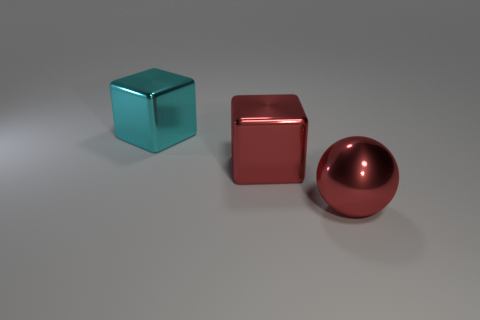Are the red object left of the ball and the large sphere made of the same material?
Offer a very short reply. Yes. Is there any other thing that is made of the same material as the sphere?
Ensure brevity in your answer.  Yes. There is a thing left of the big red object on the left side of the large red sphere; what number of metal things are on the right side of it?
Your response must be concise. 2. The red cube has what size?
Your answer should be very brief. Large. How big is the thing on the left side of the red block?
Keep it short and to the point. Large. Does the block that is to the right of the cyan shiny thing have the same color as the large ball that is in front of the big cyan block?
Provide a succinct answer. Yes. Is the number of cyan blocks in front of the big cyan cube the same as the number of big shiny objects that are to the right of the large red shiny cube?
Give a very brief answer. No. Does the large red object that is left of the red sphere have the same material as the block behind the red block?
Offer a terse response. Yes. How many other objects are there of the same size as the cyan thing?
Offer a terse response. 2. What number of things are either large yellow metallic spheres or objects left of the big red shiny cube?
Your response must be concise. 1. 